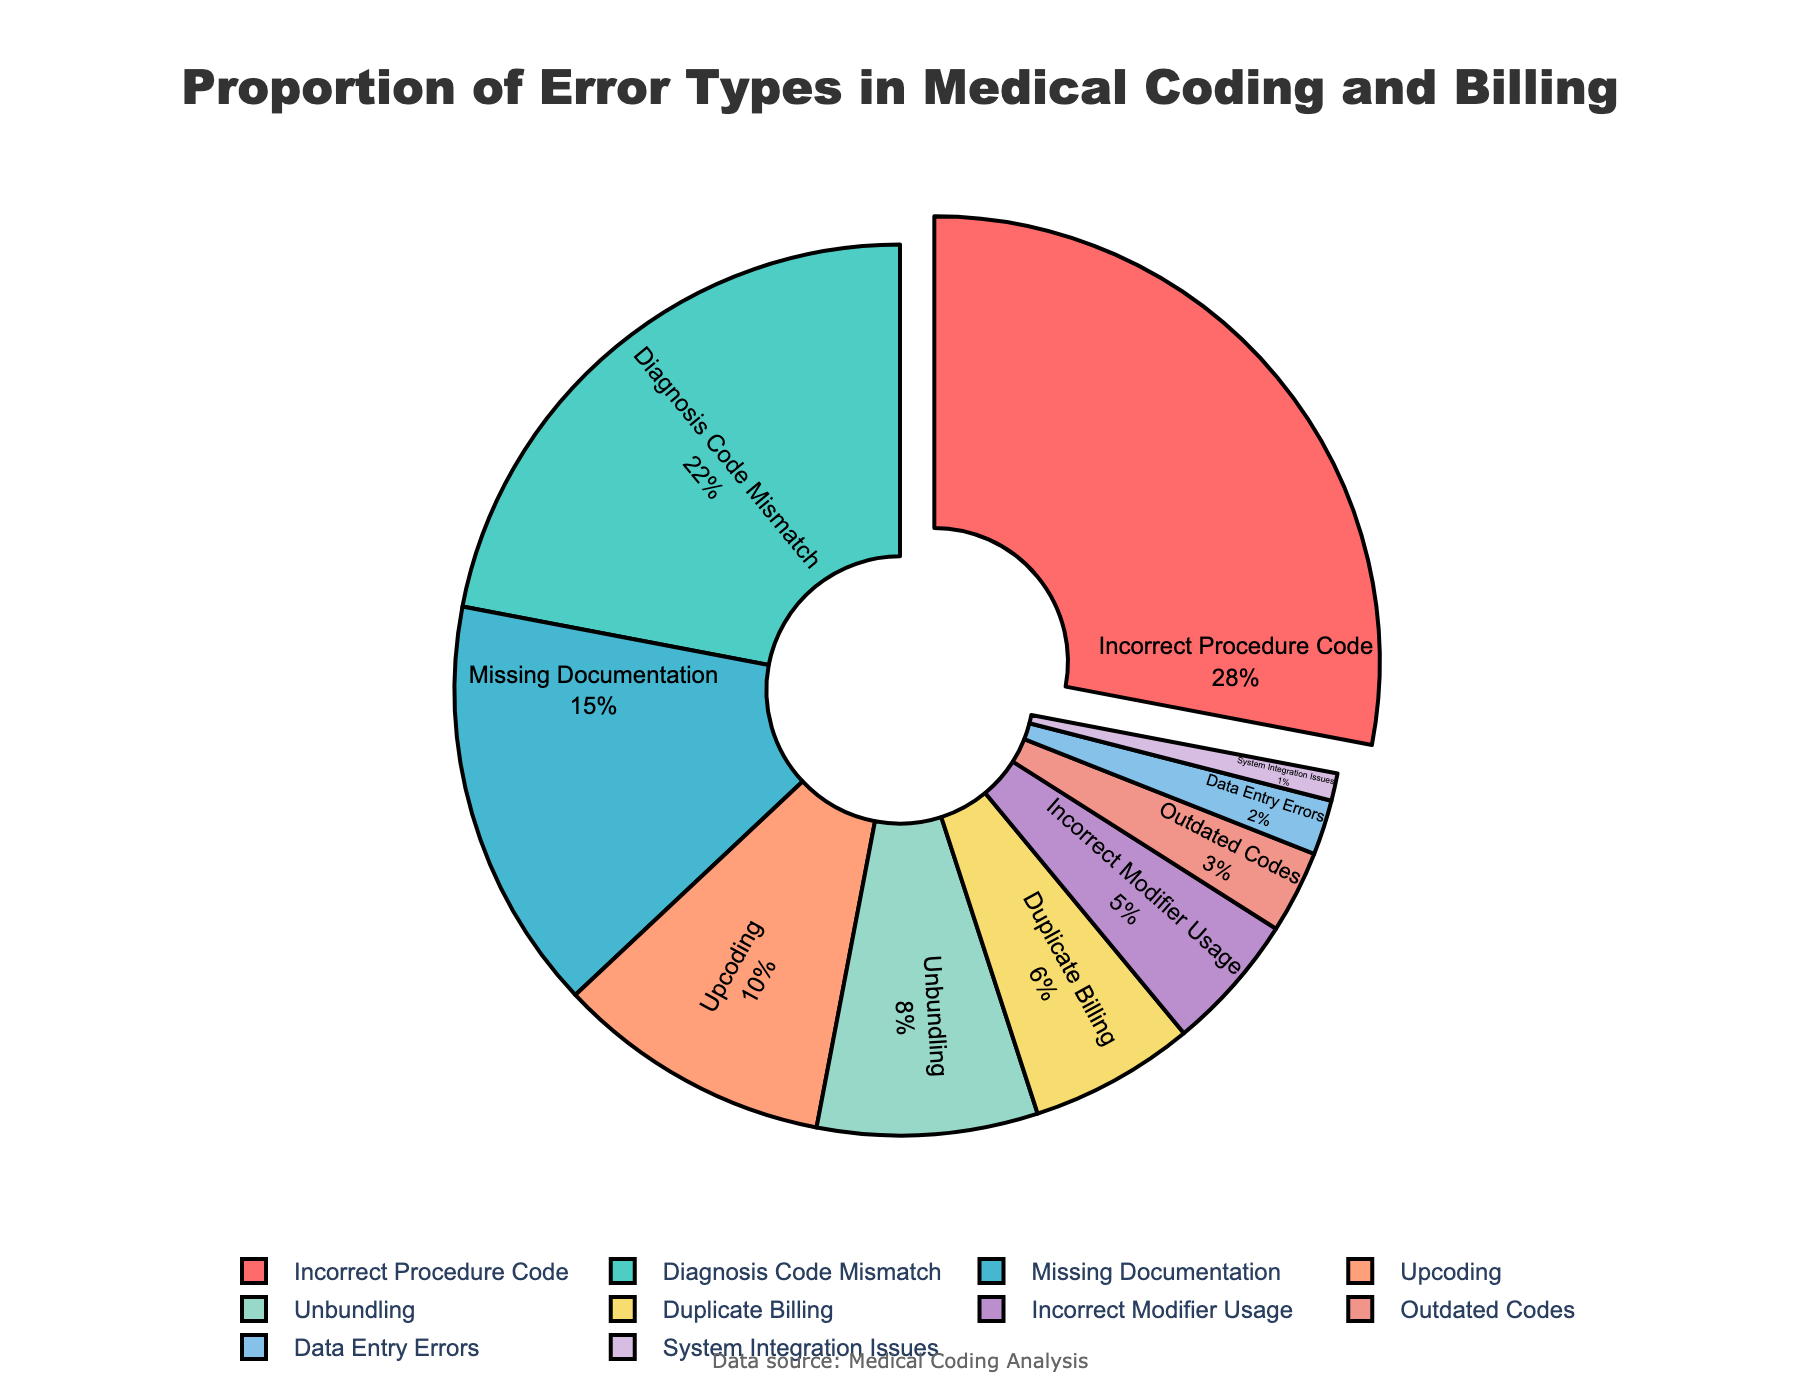What is the proportion of Incorrect Procedure Code errors in medical coding and billing? To find the proportion, refer to the section of the pie chart labeled "Incorrect Procedure Code." The percentage associated with this section is displayed within the visual.
Answer: 28% Which error type constitutes the smallest proportion? Identify the smallest section of the pie chart by visually comparing the sizes of each segment. The smallest piece corresponds to the error type labeled "System Integration Issues," which has the smallest percentage labeled.
Answer: System Integration Issues What is the combined proportion of Missing Documentation and Duplicate Billing errors? Locate the percentages labeled for "Missing Documentation" and "Duplicate Billing" errors in the pie chart. Add these two percentages together: 15% (Missing Documentation) + 6% (Duplicate Billing) = 21%.
Answer: 21% Is the proportion of Upcoding errors greater than, less than, or equal to the proportion of Unbundling errors? Visually compare the segments labeled "Upcoding" and "Unbundling" by their size and the percentages labeled on the pie chart. The Upcoding section represents 10%, and the Unbundling section represents 8%, indicating that Upcoding is greater.
Answer: Greater than How much larger is the proportion of Incorrect Procedure Code errors compared to the proportion of Incorrect Modifier Usage errors? Find the percentage labeled for "Incorrect Procedure Code" (28%) and "Incorrect Modifier Usage" (5%). Subtract the smaller percentage from the larger one: 28% - 5% = 23%.
Answer: 23% Which error type corresponds to the red section in the pie chart? Visually identify the red-colored section of the pie chart and look at the label within this section. The label reads "Incorrect Procedure Code."
Answer: Incorrect Procedure Code What is the proportion of errors that are either Missing Documentation or Upcoding? Locate the sections labeled "Missing Documentation" (15%) and "Upcoding" (10%). Add these percentages together to find the combined proportion: 15% + 10% = 25%.
Answer: 25% Which has the higher proportion: Diagnosis Code Mismatch or Duplicate Billing? Compare the sizes and the labeled percentages of the "Diagnosis Code Mismatch" section (22%) and the "Duplicate Billing" section (6%). The "Diagnosis Code Mismatch" portion is higher.
Answer: Diagnosis Code Mismatch What is the sum of the proportions for the top three most common error types? Identify the top three segments by their labeled percentages and sum them. The three largest percentages are Incorrect Procedure Code (28%), Diagnosis Code Mismatch (22%), and Missing Documentation (15%). Summing these: 28% + 22% + 15% = 65%.
Answer: 65% What is the difference between the proportion of Outdated Codes errors and Data Entry Errors? Locate the sections labeled "Outdated Codes" (3%) and "Data Entry Errors" (2%). Subtract the smaller percentage from the larger one: 3% - 2% = 1%.
Answer: 1% 